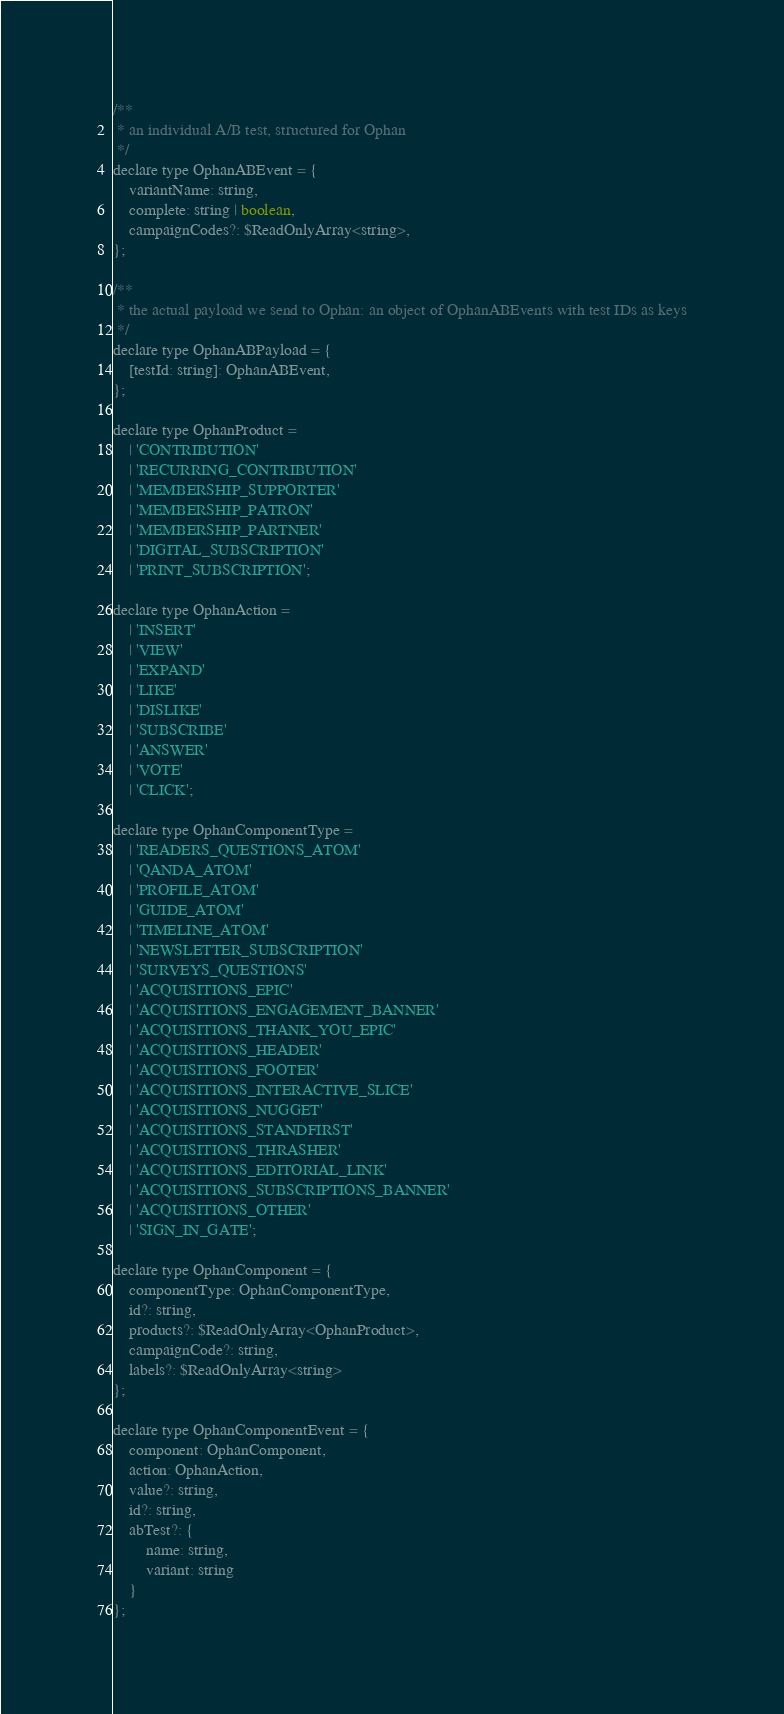<code> <loc_0><loc_0><loc_500><loc_500><_JavaScript_>/**
 * an individual A/B test, structured for Ophan
 */
declare type OphanABEvent = {
    variantName: string,
    complete: string | boolean,
    campaignCodes?: $ReadOnlyArray<string>,
};

/**
 * the actual payload we send to Ophan: an object of OphanABEvents with test IDs as keys
 */
declare type OphanABPayload = {
    [testId: string]: OphanABEvent,
};

declare type OphanProduct =
    | 'CONTRIBUTION'
    | 'RECURRING_CONTRIBUTION'
    | 'MEMBERSHIP_SUPPORTER'
    | 'MEMBERSHIP_PATRON'
    | 'MEMBERSHIP_PARTNER'
    | 'DIGITAL_SUBSCRIPTION'
    | 'PRINT_SUBSCRIPTION';

declare type OphanAction =
    | 'INSERT'
    | 'VIEW'
    | 'EXPAND'
    | 'LIKE'
    | 'DISLIKE'
    | 'SUBSCRIBE'
    | 'ANSWER'
    | 'VOTE'
    | 'CLICK';

declare type OphanComponentType =
    | 'READERS_QUESTIONS_ATOM'
    | 'QANDA_ATOM'
    | 'PROFILE_ATOM'
    | 'GUIDE_ATOM'
    | 'TIMELINE_ATOM'
    | 'NEWSLETTER_SUBSCRIPTION'
    | 'SURVEYS_QUESTIONS'
    | 'ACQUISITIONS_EPIC'
    | 'ACQUISITIONS_ENGAGEMENT_BANNER'
    | 'ACQUISITIONS_THANK_YOU_EPIC'
    | 'ACQUISITIONS_HEADER'
    | 'ACQUISITIONS_FOOTER'
    | 'ACQUISITIONS_INTERACTIVE_SLICE'
    | 'ACQUISITIONS_NUGGET'
    | 'ACQUISITIONS_STANDFIRST'
    | 'ACQUISITIONS_THRASHER'
    | 'ACQUISITIONS_EDITORIAL_LINK'
    | 'ACQUISITIONS_SUBSCRIPTIONS_BANNER'
    | 'ACQUISITIONS_OTHER'
    | 'SIGN_IN_GATE';

declare type OphanComponent = {
    componentType: OphanComponentType,
    id?: string,
    products?: $ReadOnlyArray<OphanProduct>,
    campaignCode?: string,
    labels?: $ReadOnlyArray<string>
};

declare type OphanComponentEvent = {
    component: OphanComponent,
    action: OphanAction,
    value?: string,
    id?: string,
    abTest?: {
        name: string,
        variant: string
    }
};
</code> 